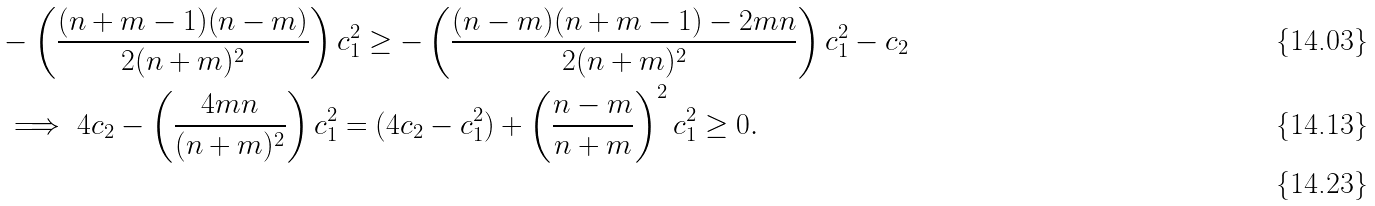<formula> <loc_0><loc_0><loc_500><loc_500>& - \left ( \frac { ( n + m - 1 ) ( n - m ) } { 2 ( n + m ) ^ { 2 } } \right ) c _ { 1 } ^ { 2 } \geq - \left ( \frac { ( n - m ) ( n + m - 1 ) - 2 m n } { 2 ( n + m ) ^ { 2 } } \right ) c _ { 1 } ^ { 2 } - c _ { 2 } \\ & \implies 4 c _ { 2 } - \left ( \frac { 4 m n } { ( n + m ) ^ { 2 } } \right ) c _ { 1 } ^ { 2 } = ( 4 c _ { 2 } - c _ { 1 } ^ { 2 } ) + \left ( \frac { n - m } { n + m } \right ) ^ { 2 } c _ { 1 } ^ { 2 } \geq 0 . \\</formula> 